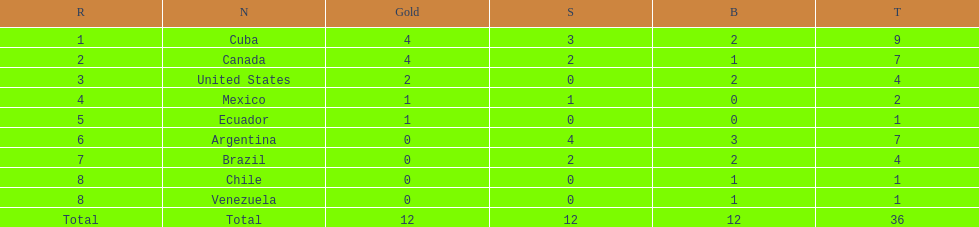Who is ranked #1? Cuba. 